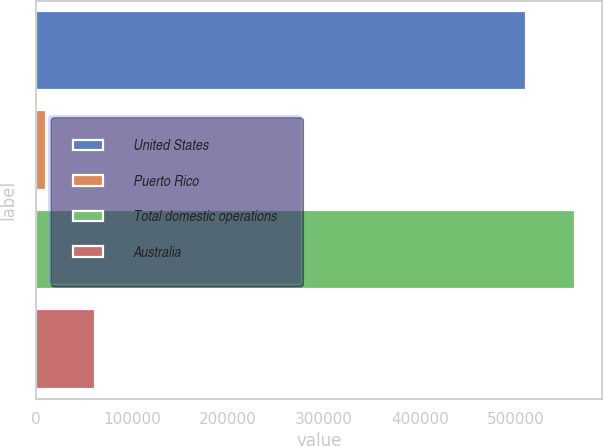<chart> <loc_0><loc_0><loc_500><loc_500><bar_chart><fcel>United States<fcel>Puerto Rico<fcel>Total domestic operations<fcel>Australia<nl><fcel>510669<fcel>10033<fcel>561736<fcel>61099.9<nl></chart> 